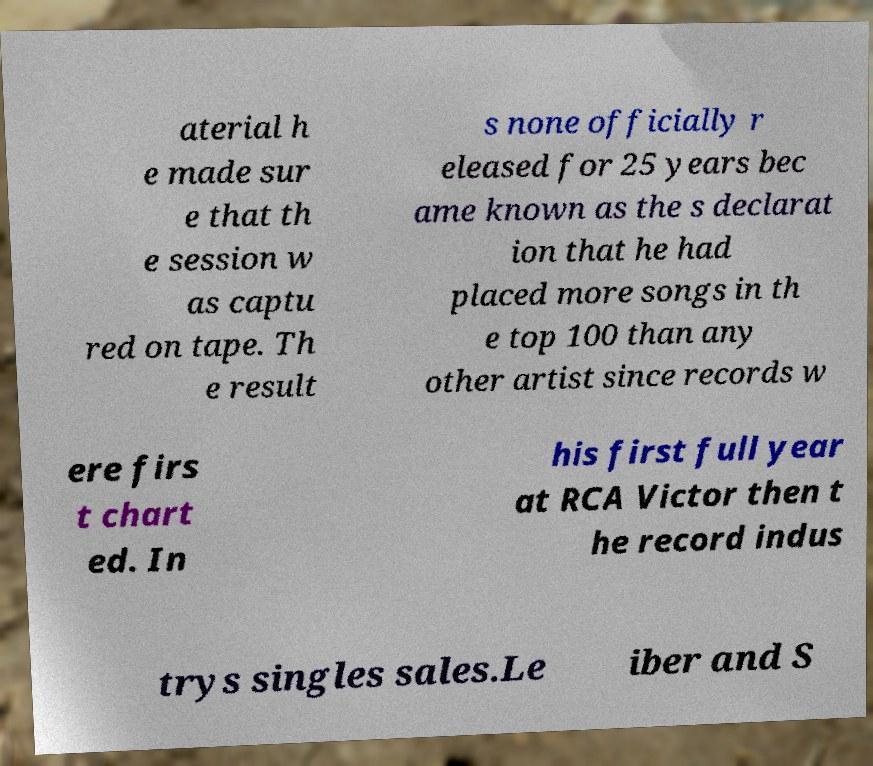Could you assist in decoding the text presented in this image and type it out clearly? aterial h e made sur e that th e session w as captu red on tape. Th e result s none officially r eleased for 25 years bec ame known as the s declarat ion that he had placed more songs in th e top 100 than any other artist since records w ere firs t chart ed. In his first full year at RCA Victor then t he record indus trys singles sales.Le iber and S 